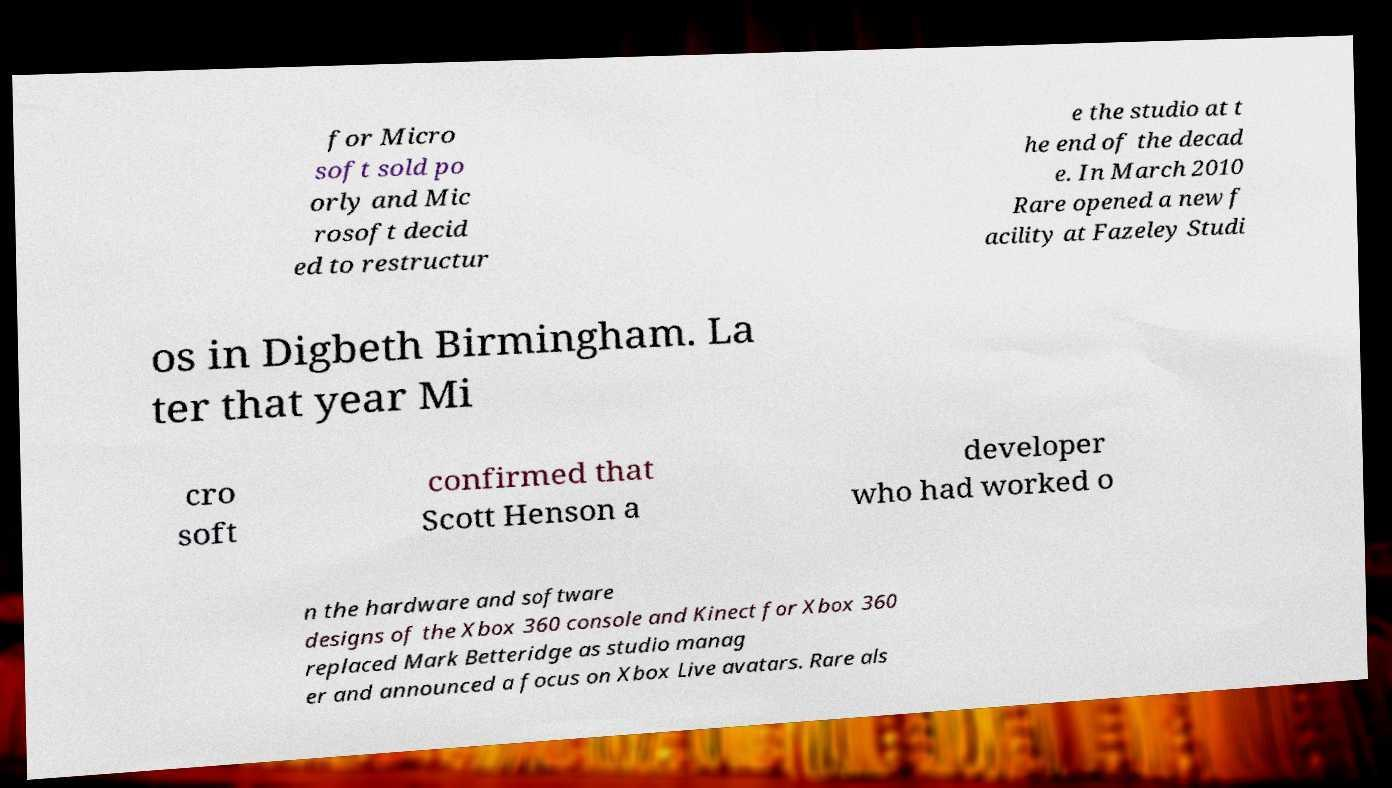What messages or text are displayed in this image? I need them in a readable, typed format. for Micro soft sold po orly and Mic rosoft decid ed to restructur e the studio at t he end of the decad e. In March 2010 Rare opened a new f acility at Fazeley Studi os in Digbeth Birmingham. La ter that year Mi cro soft confirmed that Scott Henson a developer who had worked o n the hardware and software designs of the Xbox 360 console and Kinect for Xbox 360 replaced Mark Betteridge as studio manag er and announced a focus on Xbox Live avatars. Rare als 